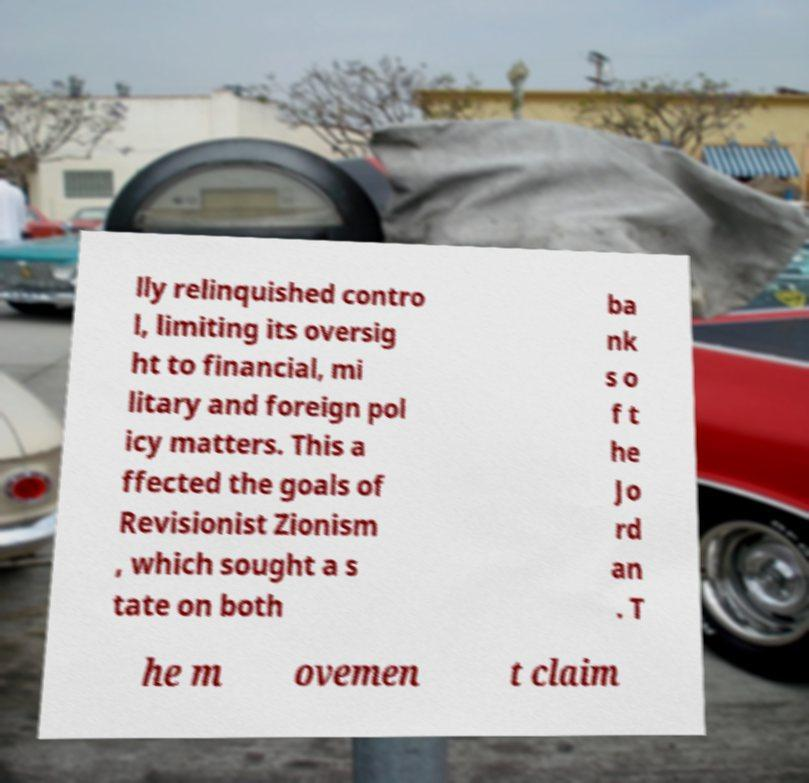Could you assist in decoding the text presented in this image and type it out clearly? lly relinquished contro l, limiting its oversig ht to financial, mi litary and foreign pol icy matters. This a ffected the goals of Revisionist Zionism , which sought a s tate on both ba nk s o f t he Jo rd an . T he m ovemen t claim 